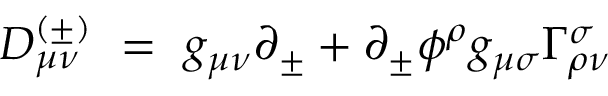<formula> <loc_0><loc_0><loc_500><loc_500>D _ { \mu \nu } ^ { ( \pm ) } = g _ { \mu \nu } \partial _ { \pm } + \partial _ { \pm } \phi ^ { \rho } g _ { \mu \sigma } \Gamma _ { \rho \nu } ^ { \sigma }</formula> 